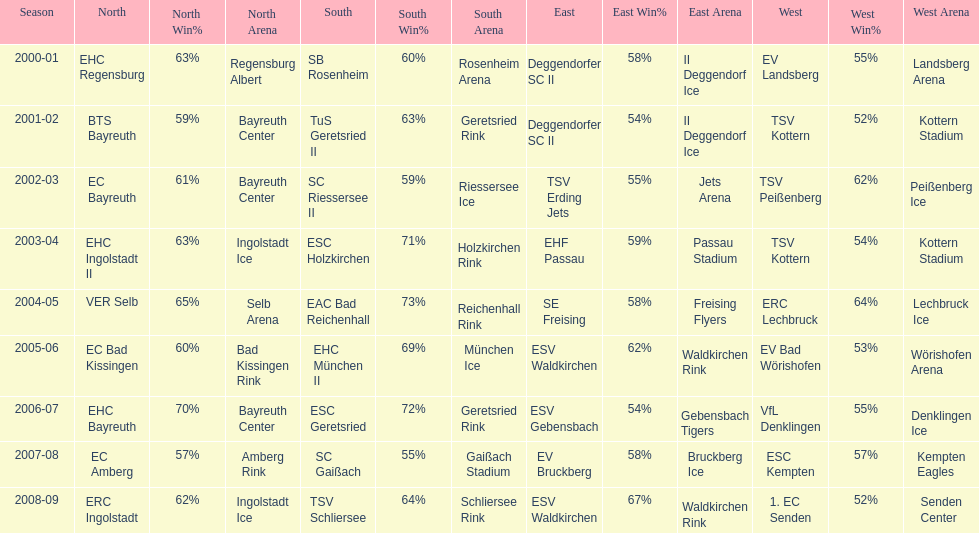What is the number of seasons covered in the table? 9. 